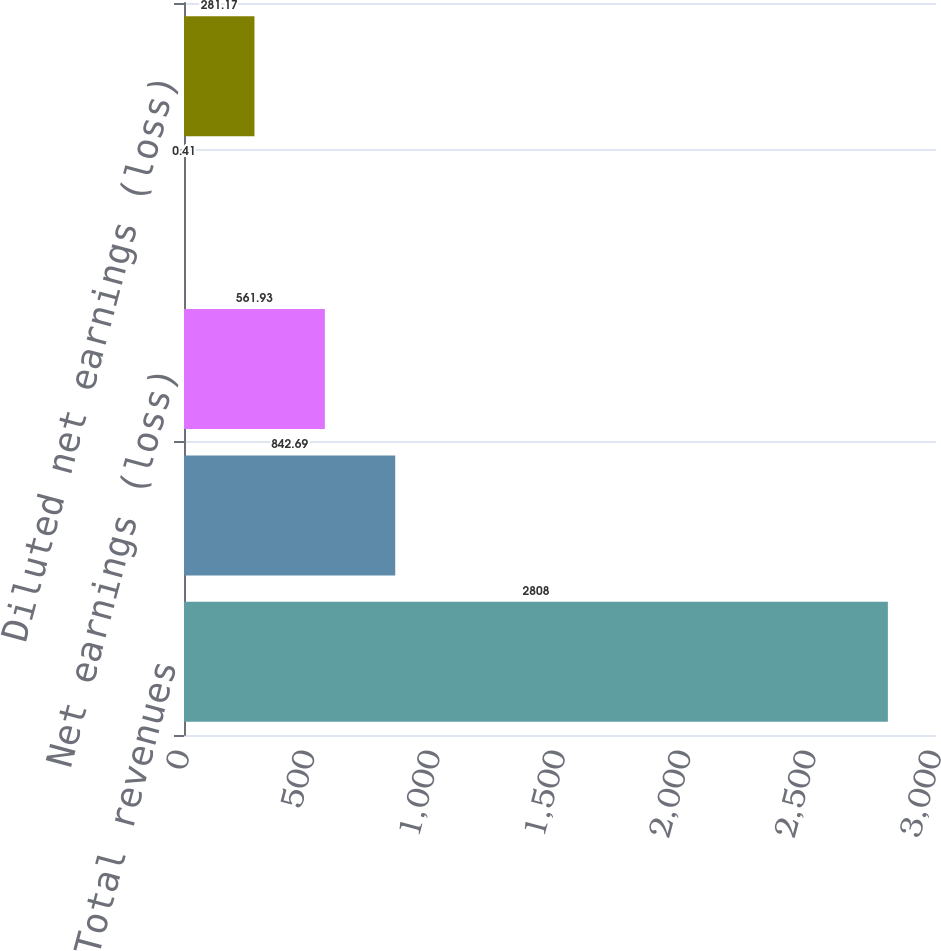<chart> <loc_0><loc_0><loc_500><loc_500><bar_chart><fcel>Total revenues<fcel>Earnings (loss) before income<fcel>Net earnings (loss)<fcel>Basic net earnings (loss) per<fcel>Diluted net earnings (loss)<nl><fcel>2808<fcel>842.69<fcel>561.93<fcel>0.41<fcel>281.17<nl></chart> 